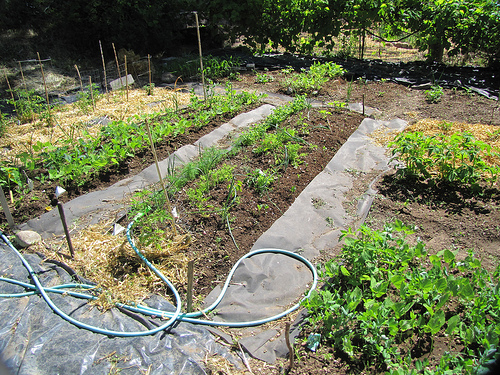<image>
Is there a tree behind the hose? Yes. From this viewpoint, the tree is positioned behind the hose, with the hose partially or fully occluding the tree. 